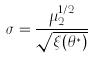Convert formula to latex. <formula><loc_0><loc_0><loc_500><loc_500>\sigma = \frac { \mu _ { 2 } ^ { 1 / 2 } } { \sqrt { \xi ( \theta ^ { * } ) } }</formula> 